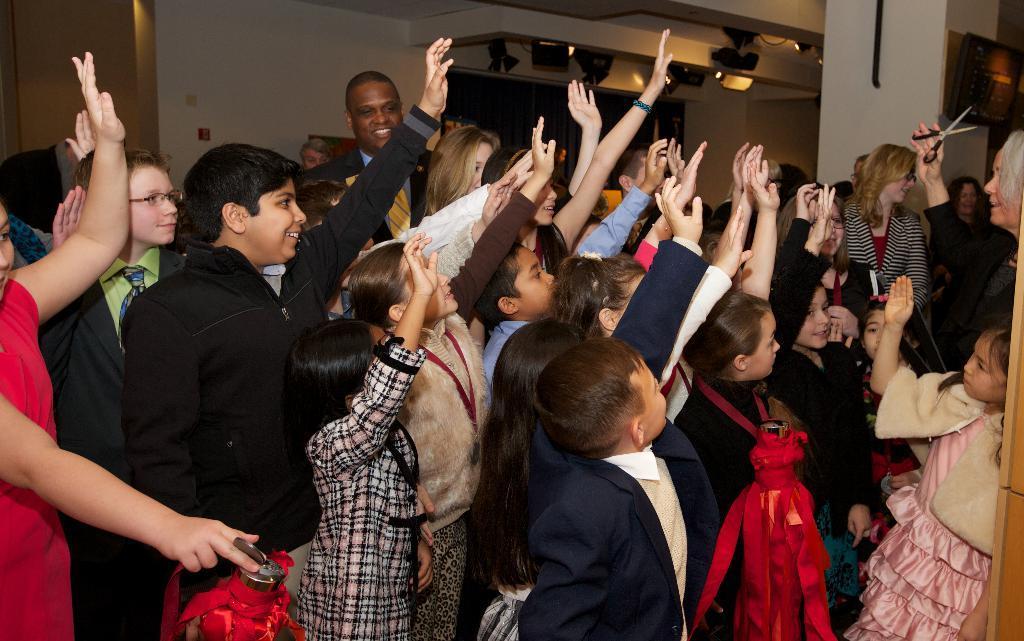Describe this image in one or two sentences. We can see group of people and we can see scissors hold with hand. In the background we can see lights and wall. 